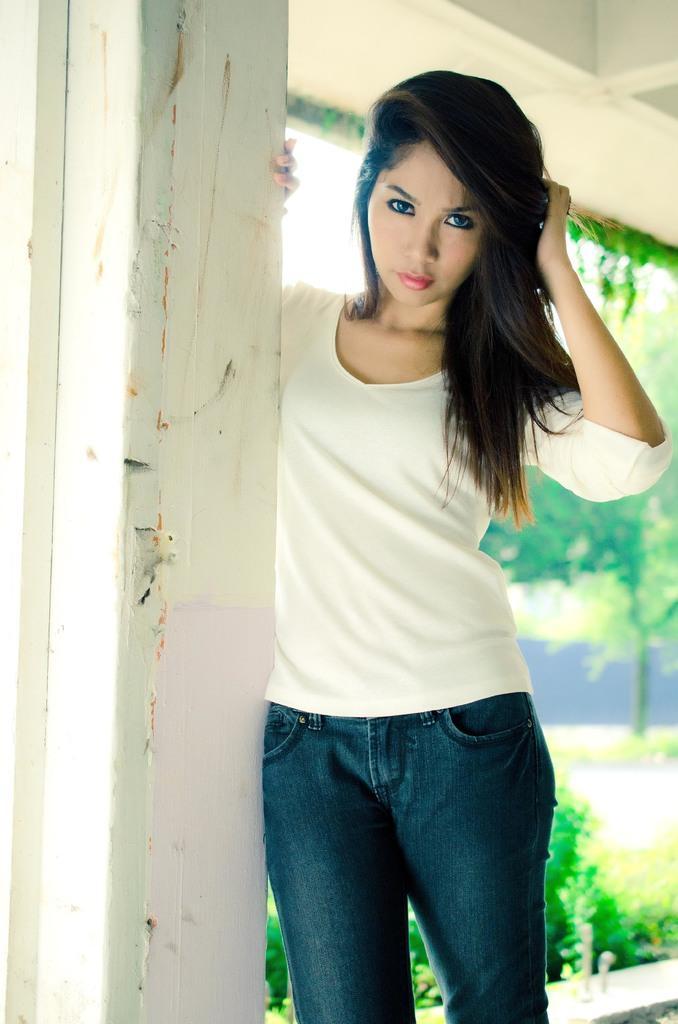Can you describe this image briefly? In the picture there is a woman standing beside a wall and posing for the photo. 